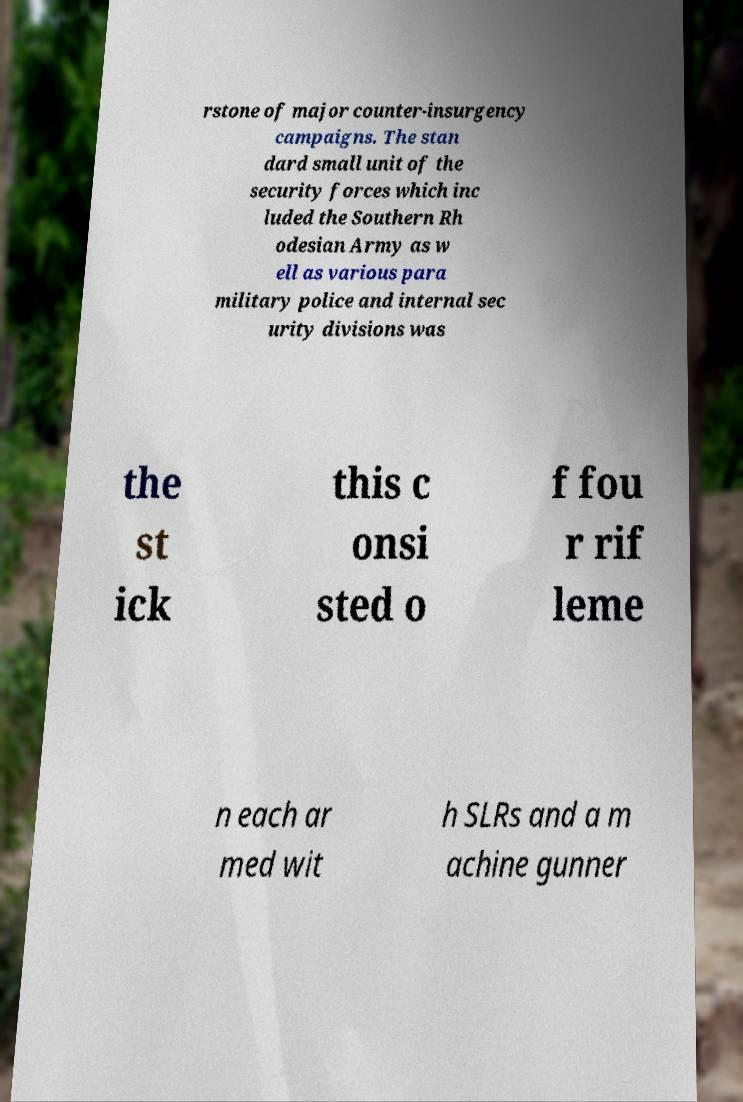Please read and relay the text visible in this image. What does it say? rstone of major counter-insurgency campaigns. The stan dard small unit of the security forces which inc luded the Southern Rh odesian Army as w ell as various para military police and internal sec urity divisions was the st ick this c onsi sted o f fou r rif leme n each ar med wit h SLRs and a m achine gunner 